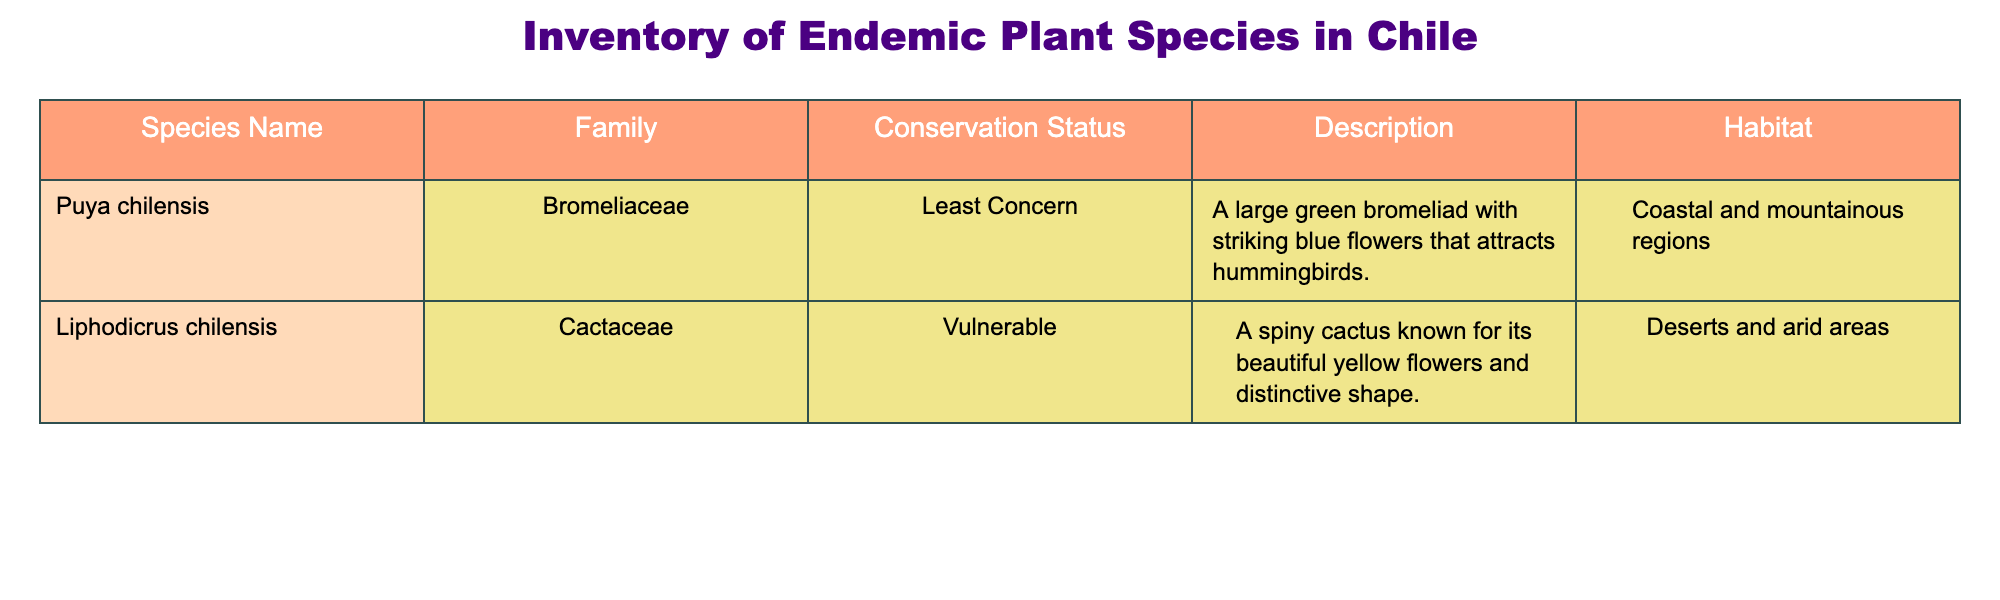What is the conservation status of Puya chilensis? Looking at the row corresponding to Puya chilensis, we can see that the conservation status is listed as "Least Concern".
Answer: Least Concern How many species in the table have a conservation status of Vulnerable? By examining the conservation status column, we see that there is one species, Liphodicrus chilensis, listed as Vulnerable.
Answer: 1 What habitat does Liphodicrus chilensis thrive in? Referring to the row for Liphodicrus chilensis, it indicates that this species occurs in "Deserts and arid areas".
Answer: Deserts and arid areas Are there any species in the table that are categorized as Endangered? Checking through the conservation status column, neither of the species listed is categorized as Endangered. Thus, the answer is no.
Answer: No What can you say about the number of families represented in the inventory? The table includes two species from two different families: Bromeliaceae and Cactaceae. Thus, there are two distinct families represented in the inventory.
Answer: 2 families What is the description for Puya chilensis? Looking at the row for Puya chilensis, the description states that it is "A large green bromeliad with striking blue flowers that attracts hummingbirds."
Answer: A large green bromeliad with striking blue flowers that attracts hummingbirds Is Liphodicrus chilensis known for having blue flowers? Referring to the description of Liphodicrus chilensis, it is noted for its "beautiful yellow flowers," indicating it does not have blue flowers. Therefore, the answer is no.
Answer: No What type of regions does Puya chilensis inhabit? The habitat for Puya chilensis, as mentioned in the table, is "Coastal and mountainous regions".
Answer: Coastal and mountainous regions If we combine the conservation statuses of both species, which one has better conservation status on average? With one species categorized as Least Concern and the other as Vulnerable, establishing a comparison is qualitative; Least Concern signifies a better status compared to Vulnerable. Thus, the average status leans towards the better conservation status of Least Concern.
Answer: Least Concern Which family has more species based on the table? There are two species, one from the Bromeliaceae family and one from the Cactaceae family. Since both families have one species, they are equally represented with no one family having more.
Answer: Equal representation 